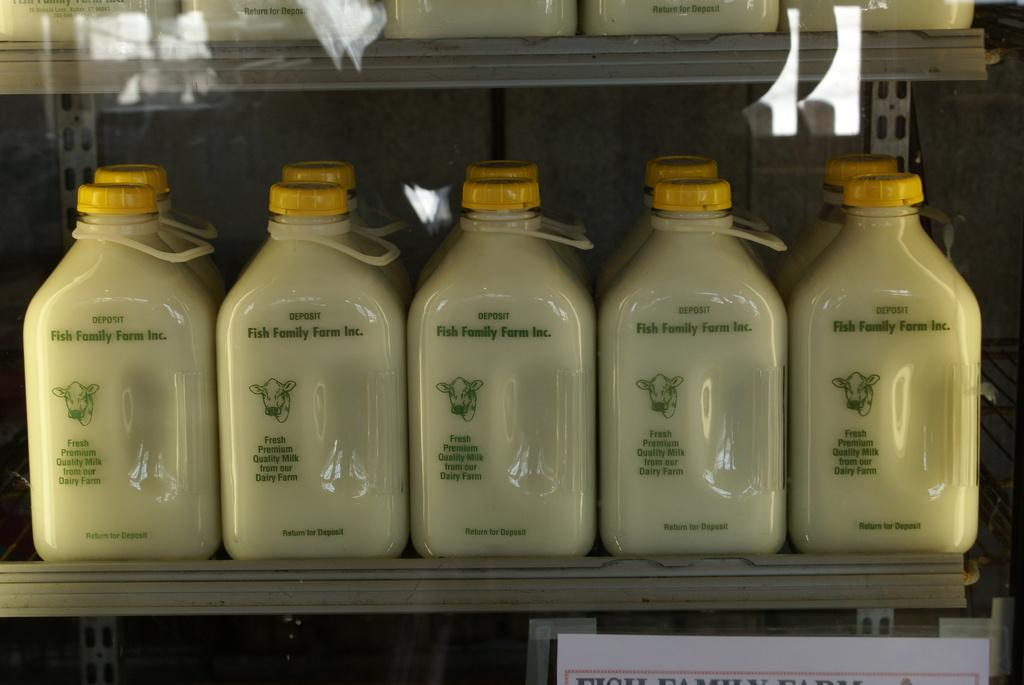What objects are present in the image? There are bottles in the image. Can you describe the bottles in the image? The bottles are the main objects visible in the image. What might the bottles be used for? The bottles could be used for storing or containing liquids or other substances. What type of machine is producing the thrill in the image? There is no machine or thrill present in the image; it only features bottles. 